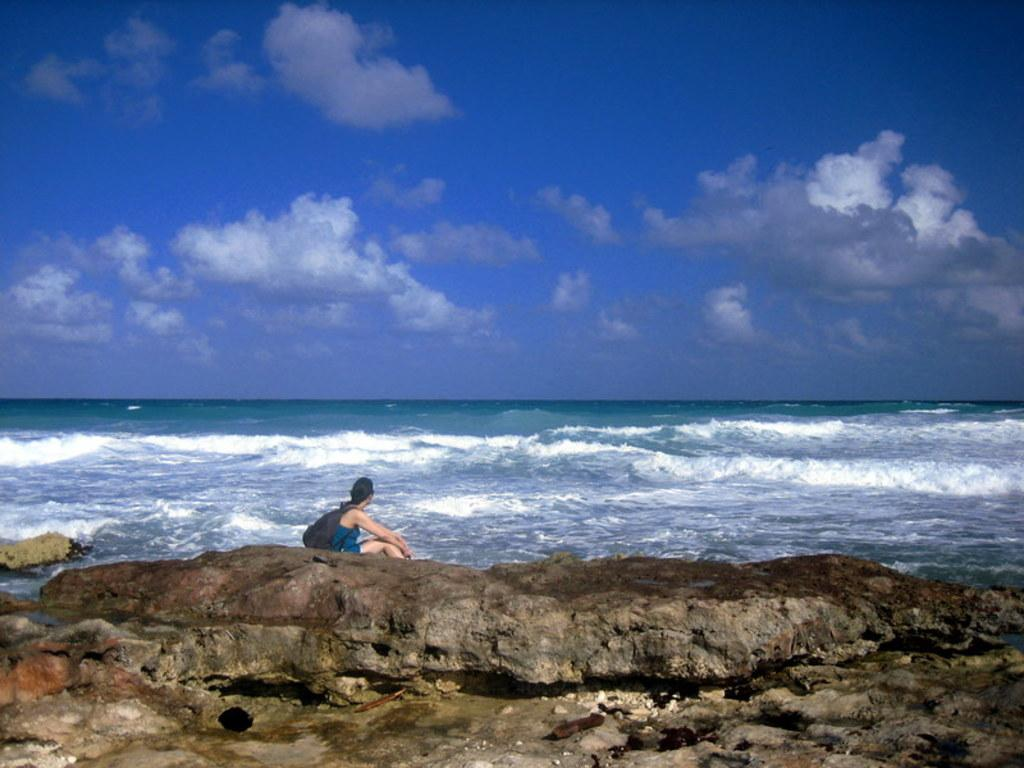Who is present in the image? There is a woman in the image. What is the woman holding or carrying? The woman is carrying a bag. What is the woman's position in the image? The woman is sitting. What type of natural elements can be seen in the image? There are rocks and water visible in the image. What can be seen in the background of the image? The sky with clouds is visible in the background of the image. What type of grip does the woman have on the picture in the image? There is no picture present in the image for the woman to have a grip on. 